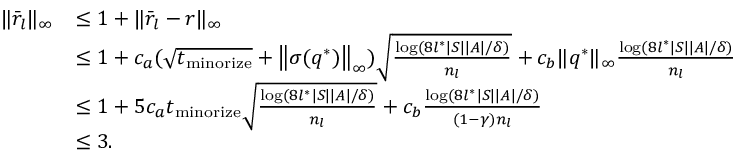Convert formula to latex. <formula><loc_0><loc_0><loc_500><loc_500>\begin{array} { r l } { \| \bar { r } _ { l } \| _ { \infty } } & { \leq 1 + \| \bar { r } _ { l } - r \| _ { \infty } } \\ & { \leq 1 + c _ { a } ( \sqrt { t _ { \min o r i z e } } + \left \| \sigma ( q ^ { * } ) \right \| _ { \infty } ) \sqrt { \frac { \log ( 8 l ^ { * } | S | | A | / \delta ) } { n _ { l } } } + c _ { b } \| q ^ { * } \| _ { \infty } \frac { \log ( 8 l ^ { * } | S | | A | / \delta ) } { n _ { l } } } \\ & { \leq 1 + 5 c _ { a } t _ { \min o r i z e } \sqrt { \frac { \log ( 8 l ^ { * } | S | | A | / \delta ) } { n _ { l } } } + c _ { b } \frac { \log ( 8 l ^ { * } | S | | A | / \delta ) } { ( 1 - \gamma ) n _ { l } } } \\ & { \leq 3 . } \end{array}</formula> 